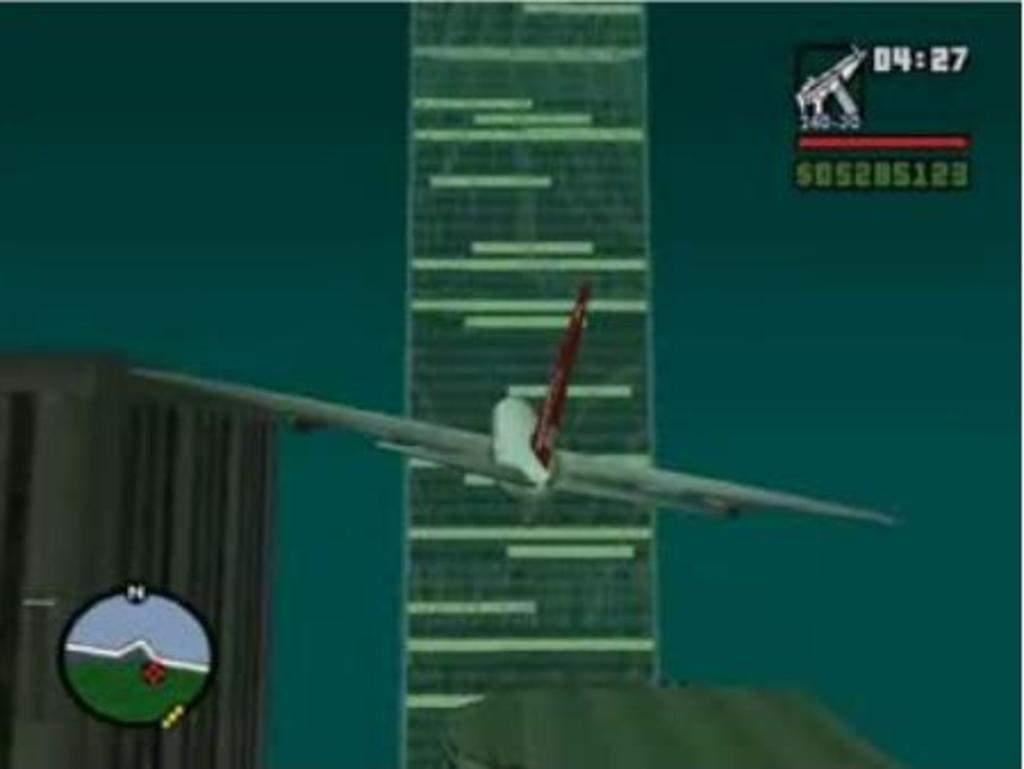What time is it in the upper right corner?
Your response must be concise. 04:27. How much money is in the top right corner?
Make the answer very short. $05285123. 